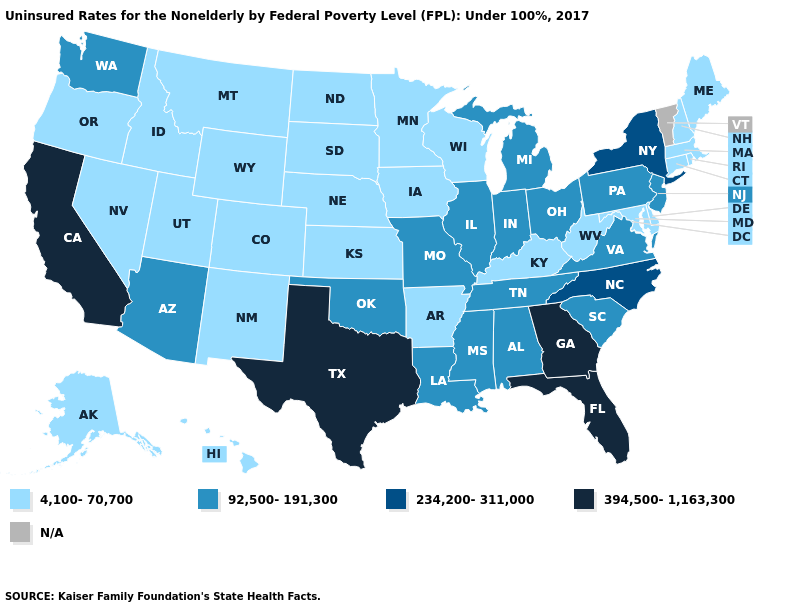What is the highest value in the USA?
Short answer required. 394,500-1,163,300. Name the states that have a value in the range 234,200-311,000?
Be succinct. New York, North Carolina. Among the states that border Arizona , which have the highest value?
Give a very brief answer. California. Name the states that have a value in the range 4,100-70,700?
Write a very short answer. Alaska, Arkansas, Colorado, Connecticut, Delaware, Hawaii, Idaho, Iowa, Kansas, Kentucky, Maine, Maryland, Massachusetts, Minnesota, Montana, Nebraska, Nevada, New Hampshire, New Mexico, North Dakota, Oregon, Rhode Island, South Dakota, Utah, West Virginia, Wisconsin, Wyoming. What is the value of Arkansas?
Keep it brief. 4,100-70,700. Name the states that have a value in the range 4,100-70,700?
Keep it brief. Alaska, Arkansas, Colorado, Connecticut, Delaware, Hawaii, Idaho, Iowa, Kansas, Kentucky, Maine, Maryland, Massachusetts, Minnesota, Montana, Nebraska, Nevada, New Hampshire, New Mexico, North Dakota, Oregon, Rhode Island, South Dakota, Utah, West Virginia, Wisconsin, Wyoming. Does Michigan have the lowest value in the MidWest?
Give a very brief answer. No. How many symbols are there in the legend?
Give a very brief answer. 5. How many symbols are there in the legend?
Short answer required. 5. Among the states that border South Dakota , which have the highest value?
Keep it brief. Iowa, Minnesota, Montana, Nebraska, North Dakota, Wyoming. Name the states that have a value in the range 394,500-1,163,300?
Concise answer only. California, Florida, Georgia, Texas. Among the states that border Virginia , which have the lowest value?
Keep it brief. Kentucky, Maryland, West Virginia. What is the value of Kentucky?
Short answer required. 4,100-70,700. 